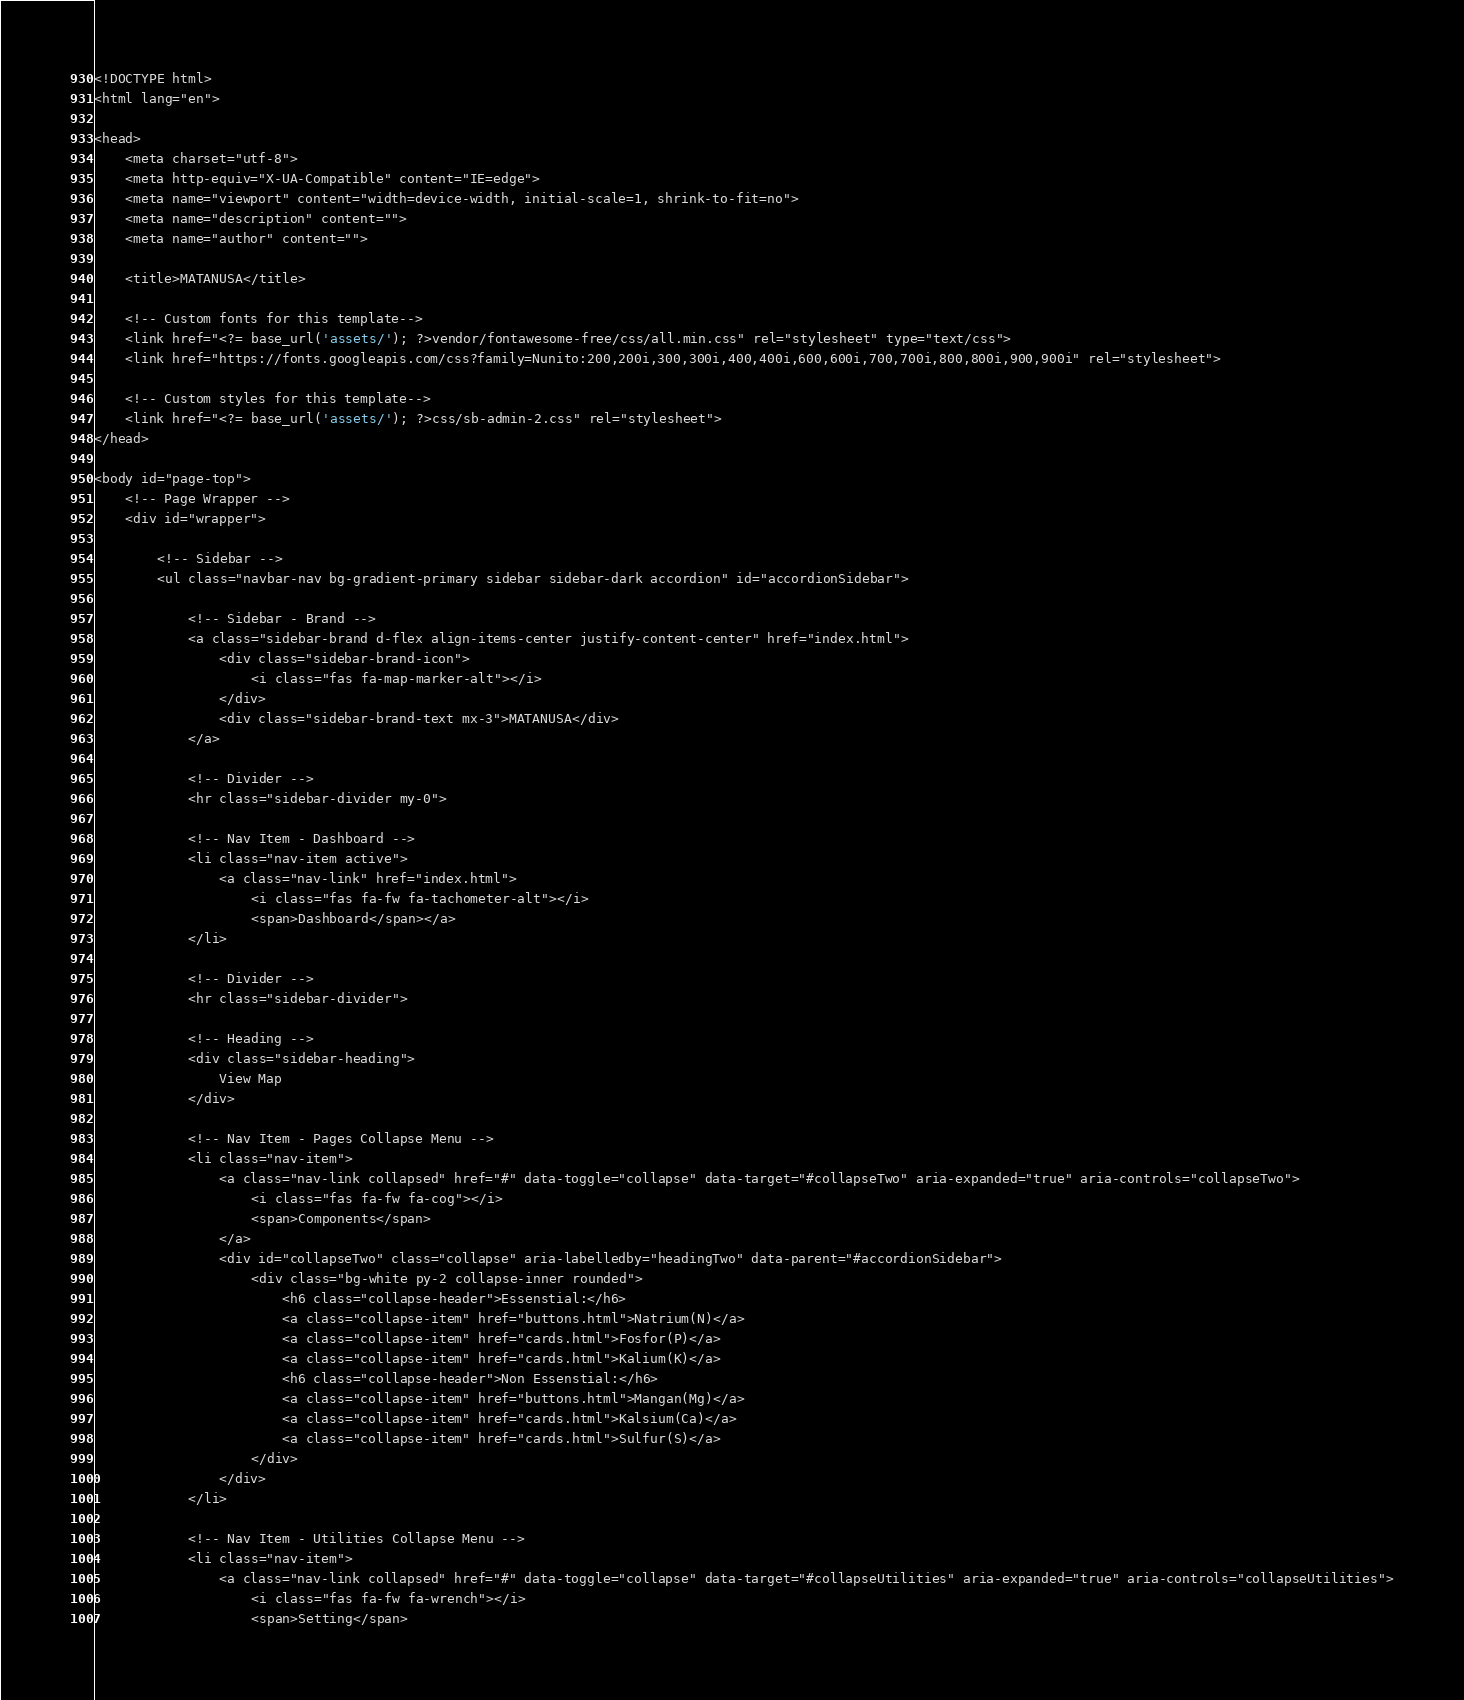Convert code to text. <code><loc_0><loc_0><loc_500><loc_500><_PHP_><!DOCTYPE html>
<html lang="en">

<head>
    <meta charset="utf-8">
    <meta http-equiv="X-UA-Compatible" content="IE=edge">
    <meta name="viewport" content="width=device-width, initial-scale=1, shrink-to-fit=no">
    <meta name="description" content="">
    <meta name="author" content="">

    <title>MATANUSA</title>

    <!-- Custom fonts for this template-->
    <link href="<?= base_url('assets/'); ?>vendor/fontawesome-free/css/all.min.css" rel="stylesheet" type="text/css">
    <link href="https://fonts.googleapis.com/css?family=Nunito:200,200i,300,300i,400,400i,600,600i,700,700i,800,800i,900,900i" rel="stylesheet">

    <!-- Custom styles for this template-->
    <link href="<?= base_url('assets/'); ?>css/sb-admin-2.css" rel="stylesheet">
</head>

<body id="page-top">
    <!-- Page Wrapper -->
    <div id="wrapper">

        <!-- Sidebar -->
        <ul class="navbar-nav bg-gradient-primary sidebar sidebar-dark accordion" id="accordionSidebar">

            <!-- Sidebar - Brand -->
            <a class="sidebar-brand d-flex align-items-center justify-content-center" href="index.html">
                <div class="sidebar-brand-icon">
                    <i class="fas fa-map-marker-alt"></i>
                </div>
                <div class="sidebar-brand-text mx-3">MATANUSA</div>
            </a>

            <!-- Divider -->
            <hr class="sidebar-divider my-0">

            <!-- Nav Item - Dashboard -->
            <li class="nav-item active">
                <a class="nav-link" href="index.html">
                    <i class="fas fa-fw fa-tachometer-alt"></i>
                    <span>Dashboard</span></a>
            </li>

            <!-- Divider -->
            <hr class="sidebar-divider">

            <!-- Heading -->
            <div class="sidebar-heading">
                View Map
            </div>

            <!-- Nav Item - Pages Collapse Menu -->
            <li class="nav-item">
                <a class="nav-link collapsed" href="#" data-toggle="collapse" data-target="#collapseTwo" aria-expanded="true" aria-controls="collapseTwo">
                    <i class="fas fa-fw fa-cog"></i>
                    <span>Components</span>
                </a>
                <div id="collapseTwo" class="collapse" aria-labelledby="headingTwo" data-parent="#accordionSidebar">
                    <div class="bg-white py-2 collapse-inner rounded">
                        <h6 class="collapse-header">Essenstial:</h6>
                        <a class="collapse-item" href="buttons.html">Natrium(N)</a>
                        <a class="collapse-item" href="cards.html">Fosfor(P)</a>
                        <a class="collapse-item" href="cards.html">Kalium(K)</a>
                        <h6 class="collapse-header">Non Essenstial:</h6>
                        <a class="collapse-item" href="buttons.html">Mangan(Mg)</a>
                        <a class="collapse-item" href="cards.html">Kalsium(Ca)</a>
                        <a class="collapse-item" href="cards.html">Sulfur(S)</a>
                    </div>
                </div>
            </li>

            <!-- Nav Item - Utilities Collapse Menu -->
            <li class="nav-item">
                <a class="nav-link collapsed" href="#" data-toggle="collapse" data-target="#collapseUtilities" aria-expanded="true" aria-controls="collapseUtilities">
                    <i class="fas fa-fw fa-wrench"></i>
                    <span>Setting</span></code> 